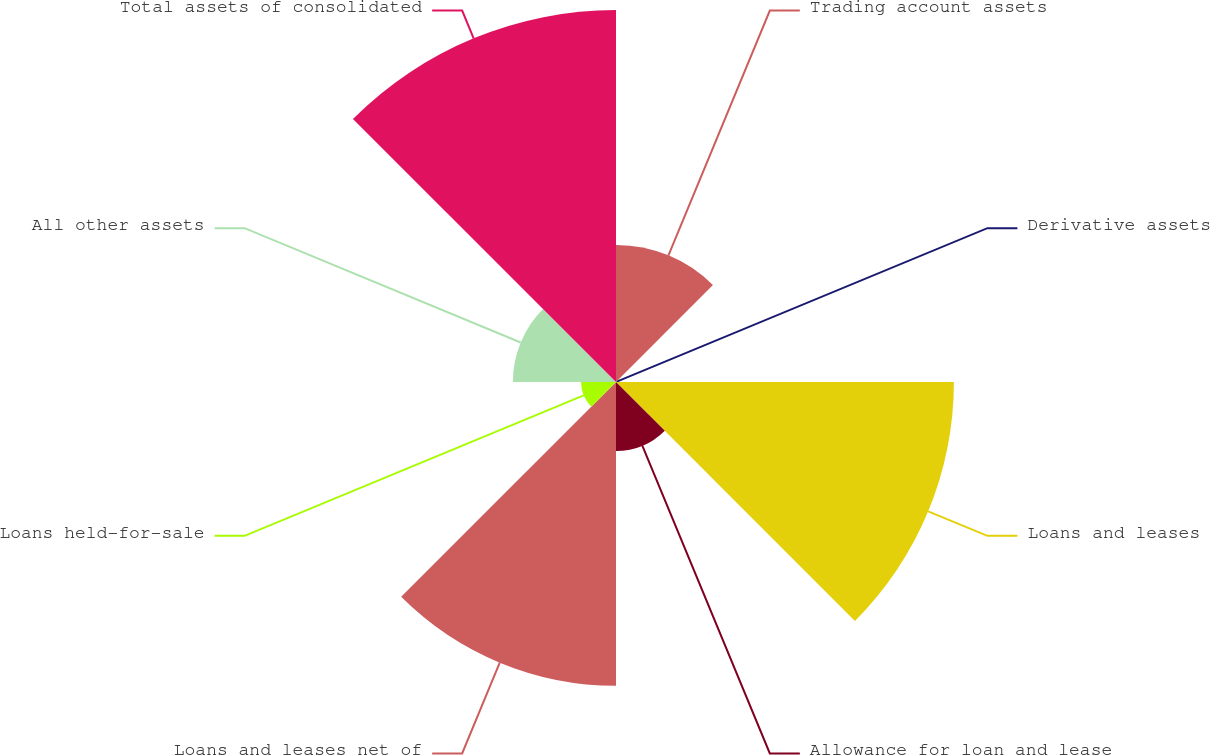<chart> <loc_0><loc_0><loc_500><loc_500><pie_chart><fcel>Trading account assets<fcel>Derivative assets<fcel>Loans and leases<fcel>Allowance for loan and lease<fcel>Loans and leases net of<fcel>Loans held-for-sale<fcel>All other assets<fcel>Total assets of consolidated<nl><fcel>10.09%<fcel>0.06%<fcel>24.87%<fcel>5.08%<fcel>22.36%<fcel>2.57%<fcel>7.59%<fcel>27.38%<nl></chart> 